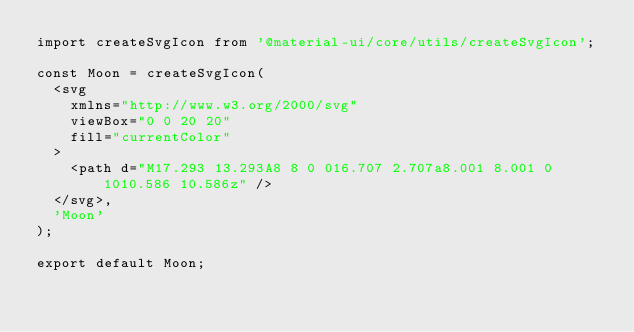<code> <loc_0><loc_0><loc_500><loc_500><_TypeScript_>import createSvgIcon from '@material-ui/core/utils/createSvgIcon';

const Moon = createSvgIcon(
  <svg
    xmlns="http://www.w3.org/2000/svg"
    viewBox="0 0 20 20"
    fill="currentColor"
  >
    <path d="M17.293 13.293A8 8 0 016.707 2.707a8.001 8.001 0 1010.586 10.586z" />
  </svg>,
  'Moon'
);

export default Moon;
</code> 